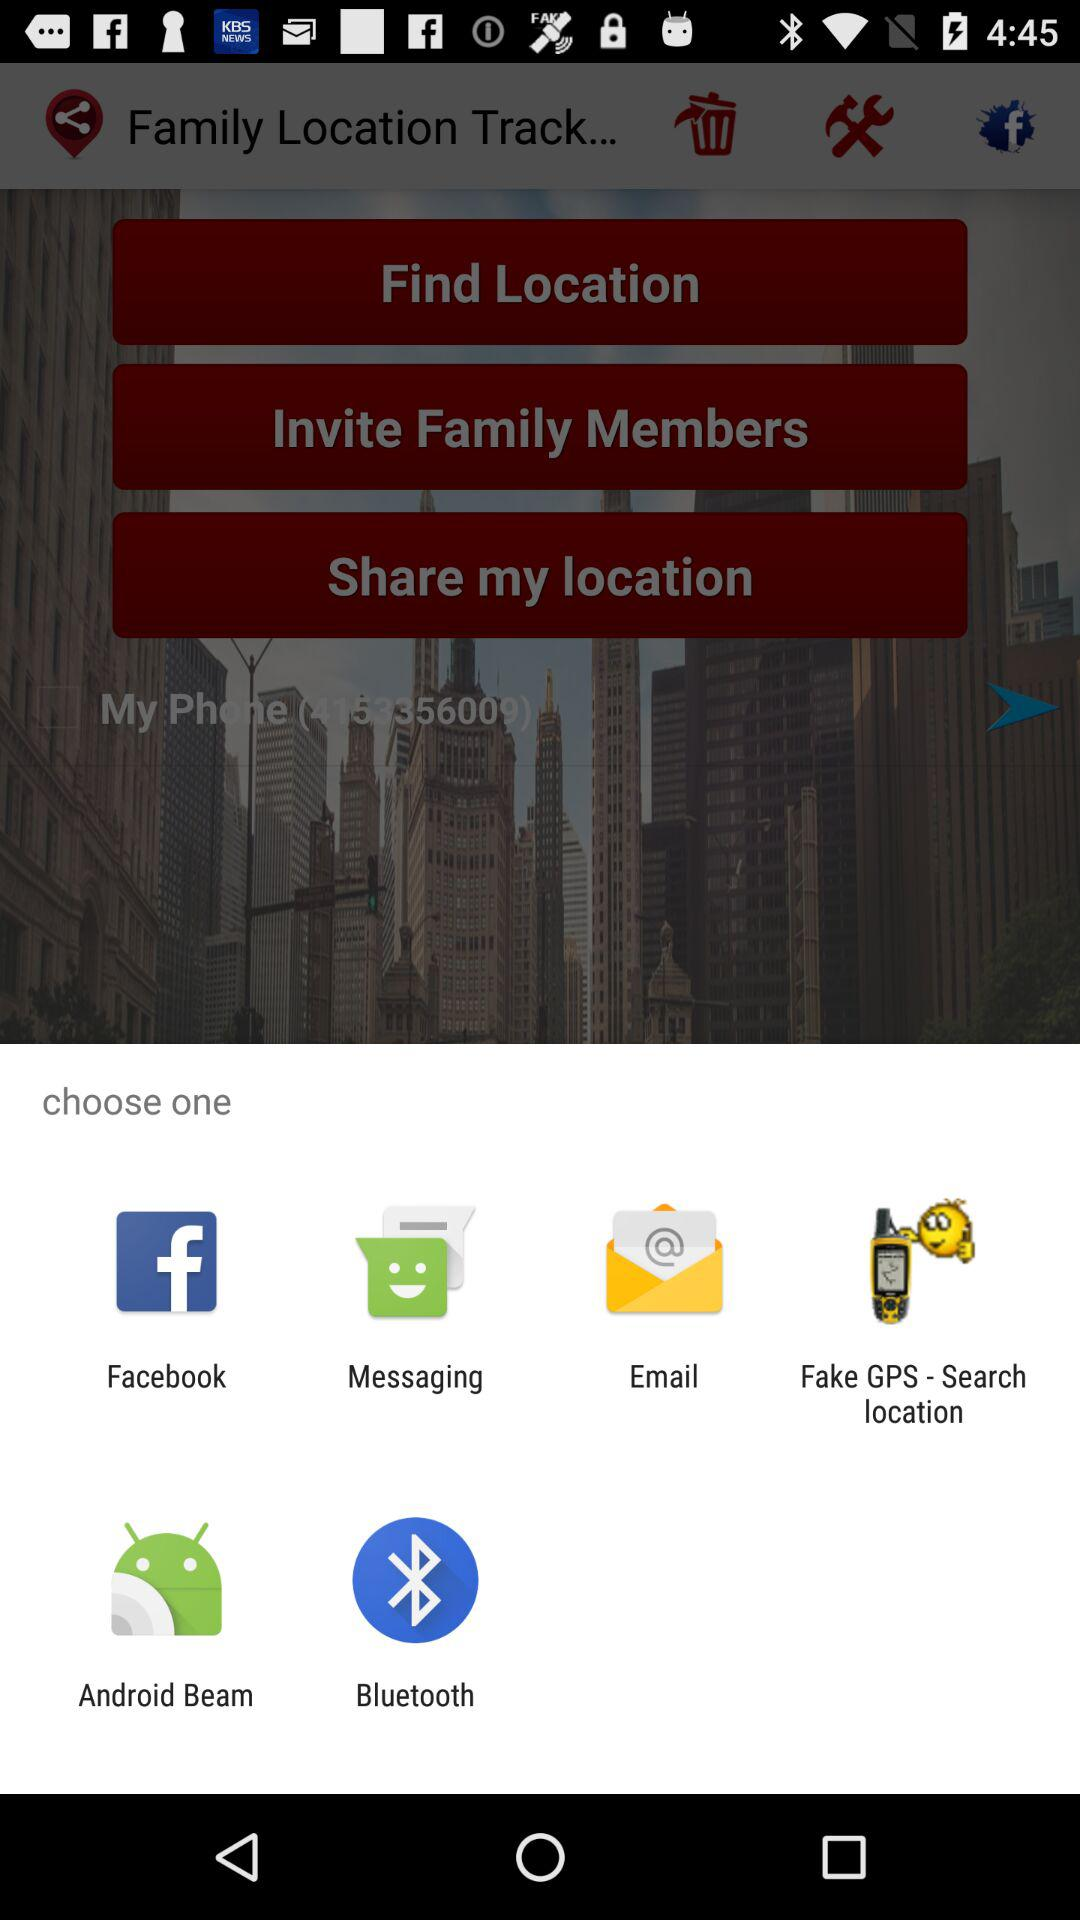What is given phone number? The given phone number is 4153356009. 